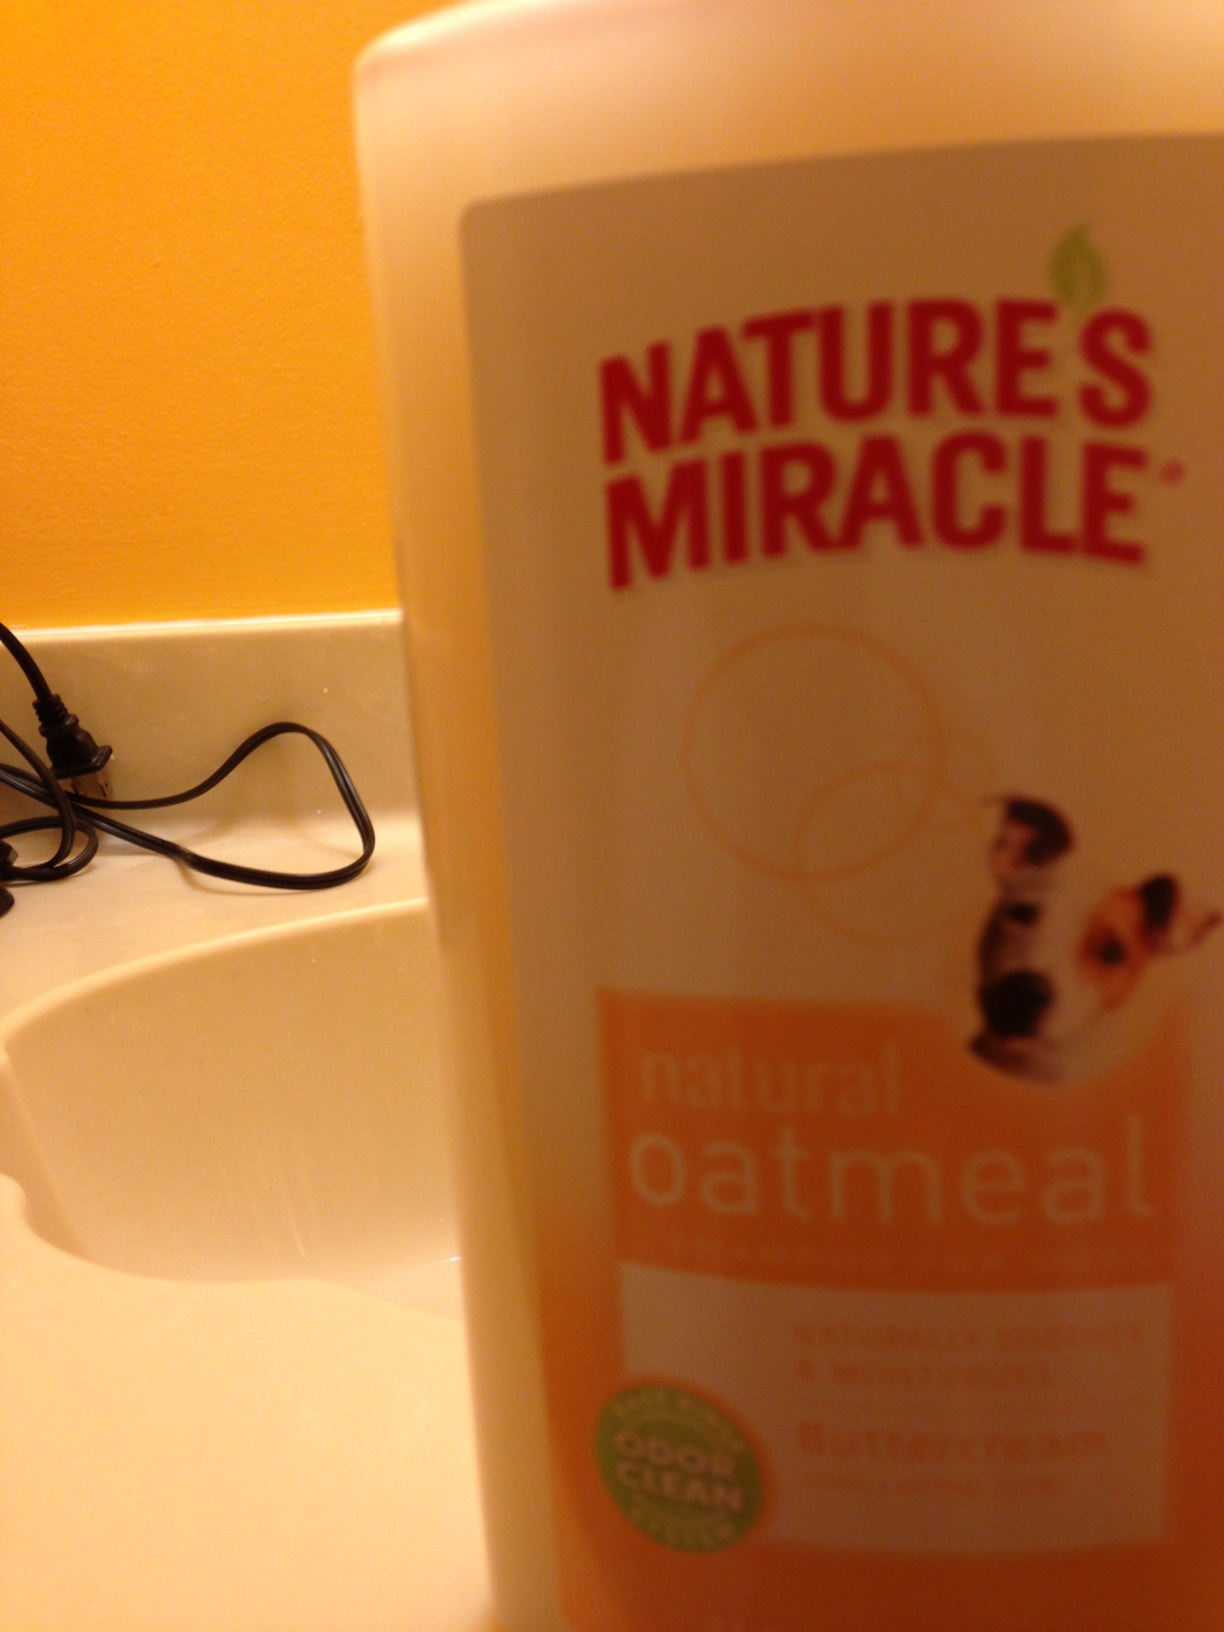What should I look for in a pet shampoo to ensure it's safe and beneficial for my dog? When choosing a pet shampoo, look for products with natural ingredients that can provide relief from skin issues, such as oatmeal for its soothing properties. Also, ensure the product is free from harsh soaps or detergents that can strip the skin's natural oils. A good pet shampoo should target odors without relying on heavy perfumes, as these can irritate a dog's sensitive skin. Additionally, check for pH balance suitable for pets and consider any specific needs your dog might have, like allergen control or flea treatment properties. 